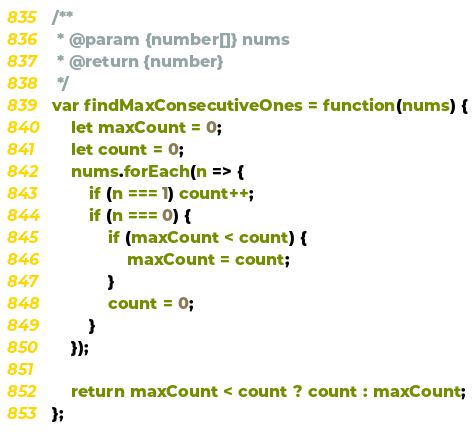Convert code to text. <code><loc_0><loc_0><loc_500><loc_500><_JavaScript_>/**
 * @param {number[]} nums
 * @return {number}
 */
var findMaxConsecutiveOnes = function(nums) {
	let maxCount = 0;
	let count = 0;
	nums.forEach(n => {
		if (n === 1) count++;
		if (n === 0) {
			if (maxCount < count) {
				maxCount = count;
			}
			count = 0;
		}
	});

	return maxCount < count ? count : maxCount;
};
</code> 